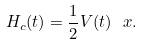Convert formula to latex. <formula><loc_0><loc_0><loc_500><loc_500>H _ { c } ( t ) = \frac { 1 } { 2 } V ( t ) \, \ x .</formula> 